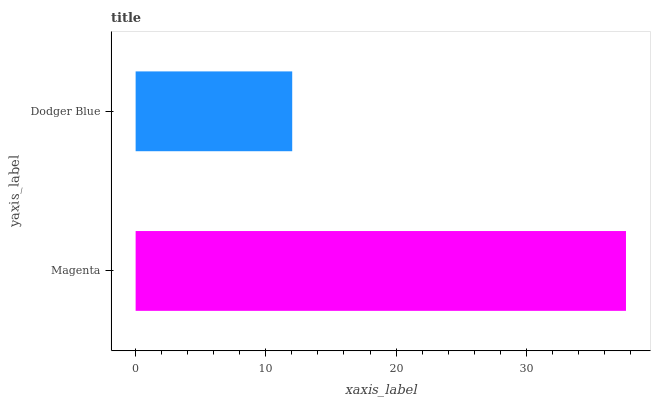Is Dodger Blue the minimum?
Answer yes or no. Yes. Is Magenta the maximum?
Answer yes or no. Yes. Is Dodger Blue the maximum?
Answer yes or no. No. Is Magenta greater than Dodger Blue?
Answer yes or no. Yes. Is Dodger Blue less than Magenta?
Answer yes or no. Yes. Is Dodger Blue greater than Magenta?
Answer yes or no. No. Is Magenta less than Dodger Blue?
Answer yes or no. No. Is Magenta the high median?
Answer yes or no. Yes. Is Dodger Blue the low median?
Answer yes or no. Yes. Is Dodger Blue the high median?
Answer yes or no. No. Is Magenta the low median?
Answer yes or no. No. 